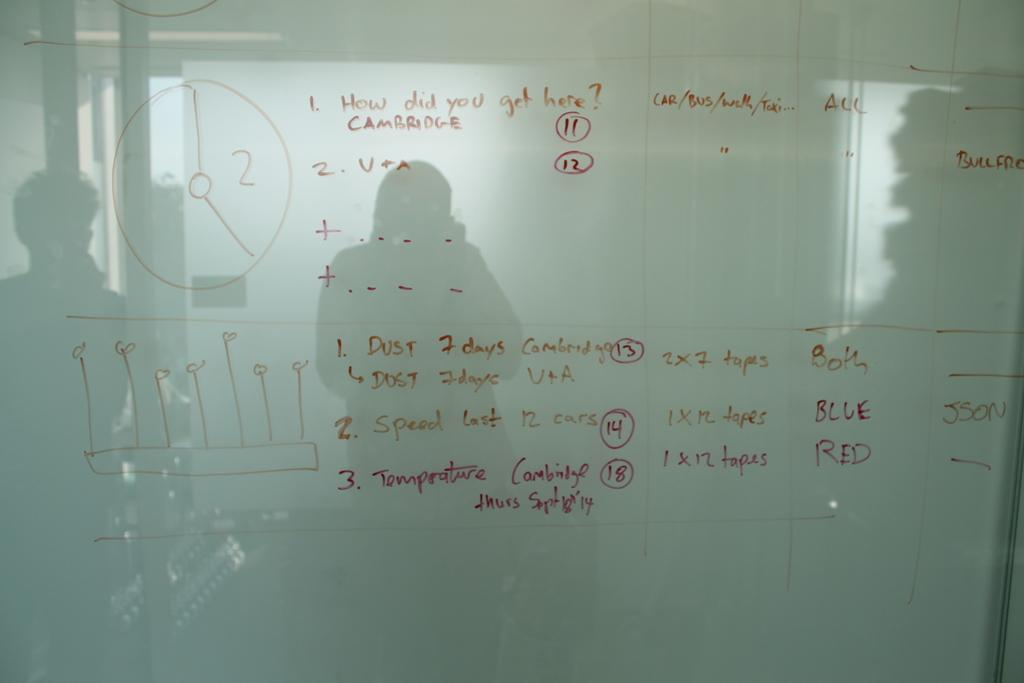<image>
Offer a succinct explanation of the picture presented. Whiteboard which says "How did you get here?" on the top. 